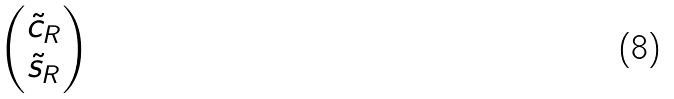Convert formula to latex. <formula><loc_0><loc_0><loc_500><loc_500>\begin{pmatrix} \tilde { c } _ { R } \\ \tilde { s } _ { R } \end{pmatrix}</formula> 